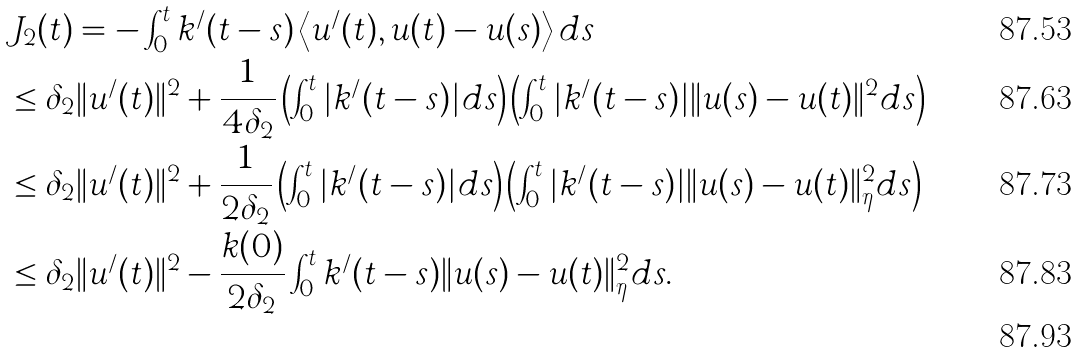Convert formula to latex. <formula><loc_0><loc_0><loc_500><loc_500>& J _ { 2 } ( t ) = - \int _ { 0 } ^ { t } k ^ { / } ( t - s ) \left < u ^ { / } ( t ) , u ( t ) - u ( s ) \right > d s \\ & \leq \delta _ { 2 } \| u ^ { / } ( t ) \| ^ { 2 } + \frac { 1 } { 4 \delta _ { 2 } } \left ( \int _ { 0 } ^ { t } | k ^ { / } ( t - s ) | d s \right ) \left ( \int _ { 0 } ^ { t } | k ^ { / } ( t - s ) | \| u ( s ) - u ( t ) \| ^ { 2 } d s \right ) \\ & \leq \delta _ { 2 } \| u ^ { / } ( t ) \| ^ { 2 } + \frac { 1 } { 2 \delta _ { 2 } } \left ( \int _ { 0 } ^ { t } | k ^ { / } ( t - s ) | d s \right ) \left ( \int _ { 0 } ^ { t } | k ^ { / } ( t - s ) | \| u ( s ) - u ( t ) \| _ { \eta } ^ { 2 } d s \right ) \\ & \leq \delta _ { 2 } \| u ^ { / } ( t ) \| ^ { 2 } - \frac { k ( 0 ) } { 2 \delta _ { 2 } } \int _ { 0 } ^ { t } k ^ { / } ( t - s ) \| u ( s ) - u ( t ) \| _ { \eta } ^ { 2 } d s . \\</formula> 